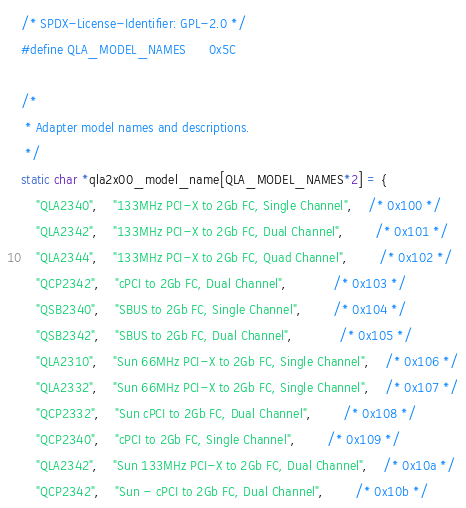Convert code to text. <code><loc_0><loc_0><loc_500><loc_500><_C_>/* SPDX-License-Identifier: GPL-2.0 */
#define QLA_MODEL_NAMES		0x5C

/*
 * Adapter model names and descriptions.
 */
static char *qla2x00_model_name[QLA_MODEL_NAMES*2] = {
	"QLA2340",	"133MHz PCI-X to 2Gb FC, Single Channel",	/* 0x100 */
	"QLA2342",	"133MHz PCI-X to 2Gb FC, Dual Channel",		/* 0x101 */
	"QLA2344",	"133MHz PCI-X to 2Gb FC, Quad Channel",		/* 0x102 */
	"QCP2342",	"cPCI to 2Gb FC, Dual Channel",			/* 0x103 */
	"QSB2340",	"SBUS to 2Gb FC, Single Channel",		/* 0x104 */
	"QSB2342",	"SBUS to 2Gb FC, Dual Channel",			/* 0x105 */
	"QLA2310",	"Sun 66MHz PCI-X to 2Gb FC, Single Channel",	/* 0x106 */
	"QLA2332",	"Sun 66MHz PCI-X to 2Gb FC, Single Channel",	/* 0x107 */
	"QCP2332",	"Sun cPCI to 2Gb FC, Dual Channel",		/* 0x108 */
	"QCP2340",	"cPCI to 2Gb FC, Single Channel",		/* 0x109 */
	"QLA2342",	"Sun 133MHz PCI-X to 2Gb FC, Dual Channel",	/* 0x10a */
	"QCP2342",	"Sun - cPCI to 2Gb FC, Dual Channel",		/* 0x10b */</code> 